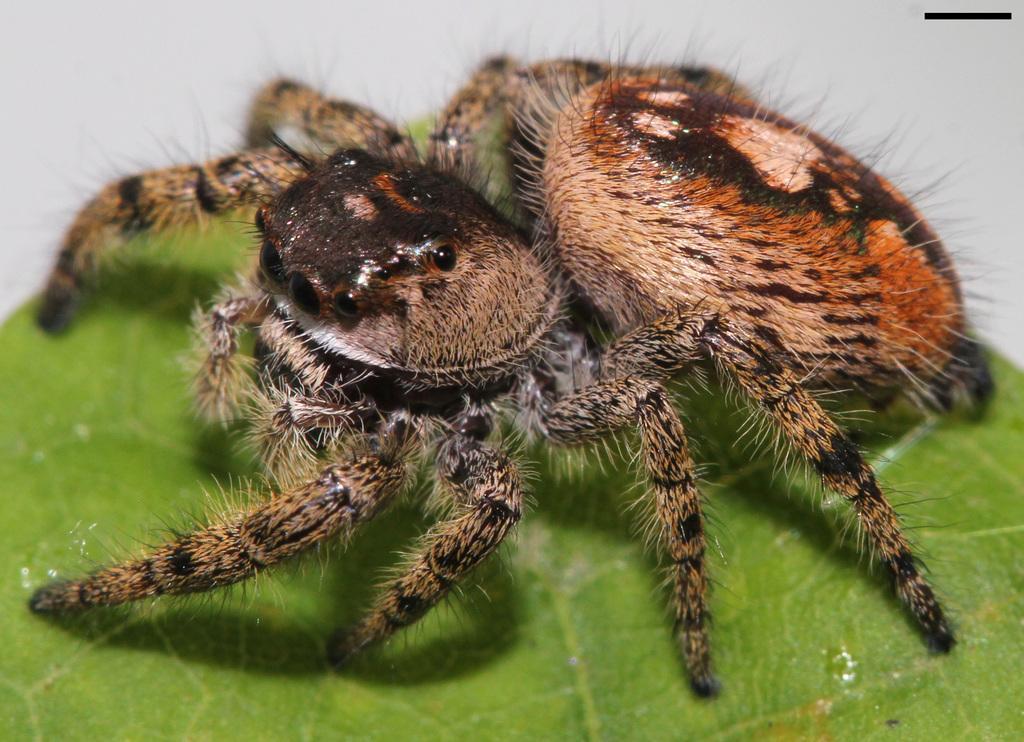Please provide a concise description of this image. In the center of the image we can see an insect is present on the leaf. 